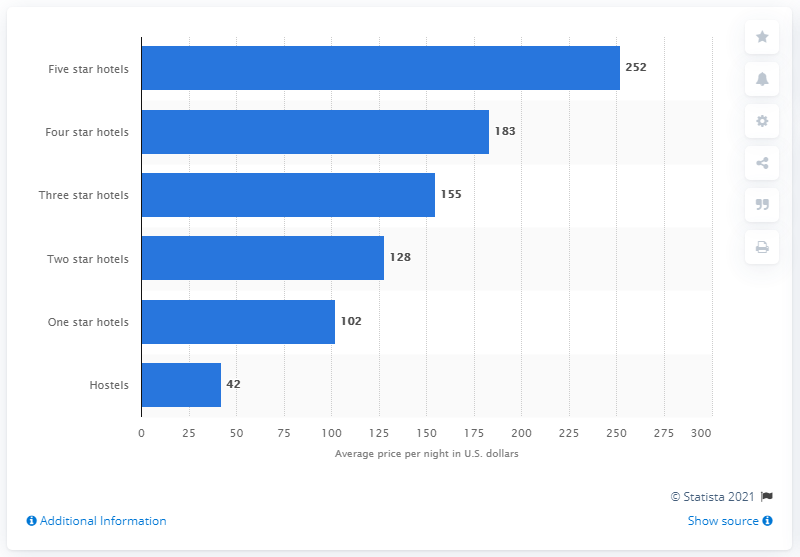Specify some key components in this picture. The average cost of a five-star hotel per night is approximately 252 USD. 